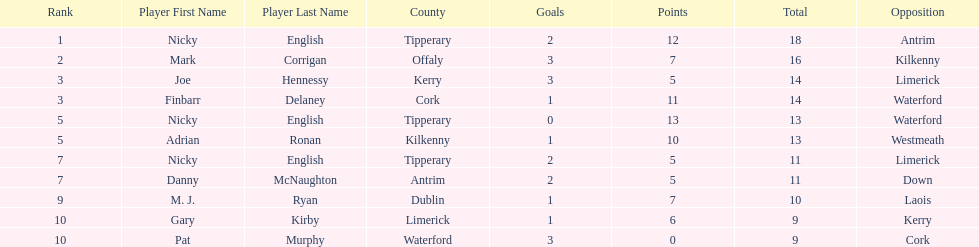Joe hennessy and finbarr delaney both scored how many points? 14. 